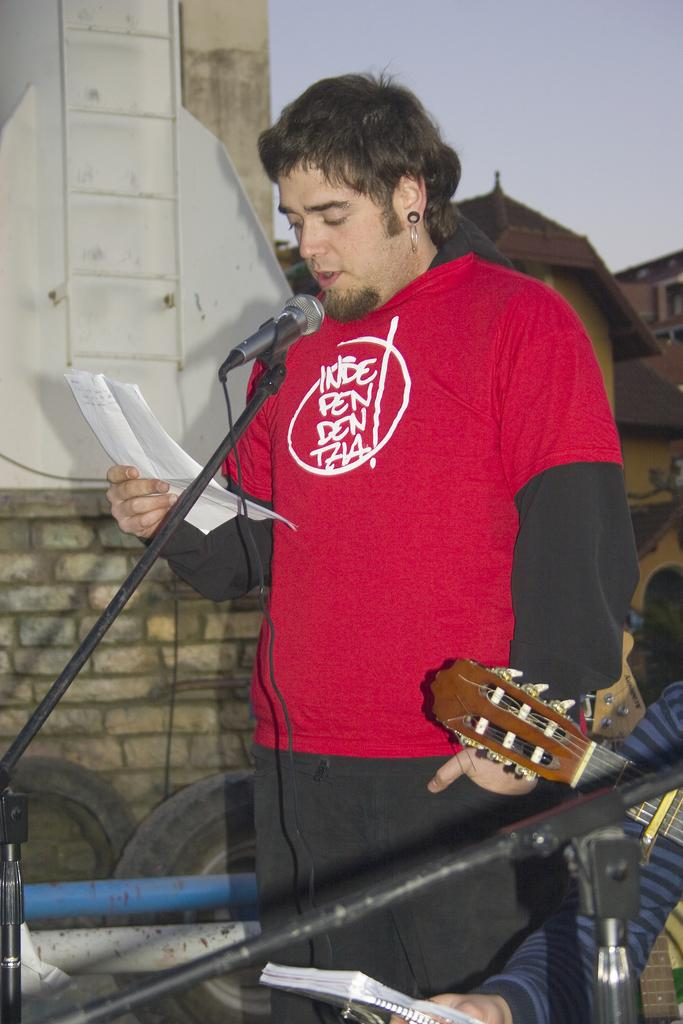What is the man in the image doing? The man is standing and singing in the image. What is the man using while singing? The man is using a microphone while singing. What is the man holding in his hand? The man is holding a paper in his hand. What is the position of the man's hand? The man has his hand raised. What is the other man in the image doing? The other man is seated and holding a guitar. What type of agreement is being signed by the man in the image? There is no indication in the image that the man is signing any agreement. Can you tell me how many bottles are visible in the image? There are no bottles visible in the image. 